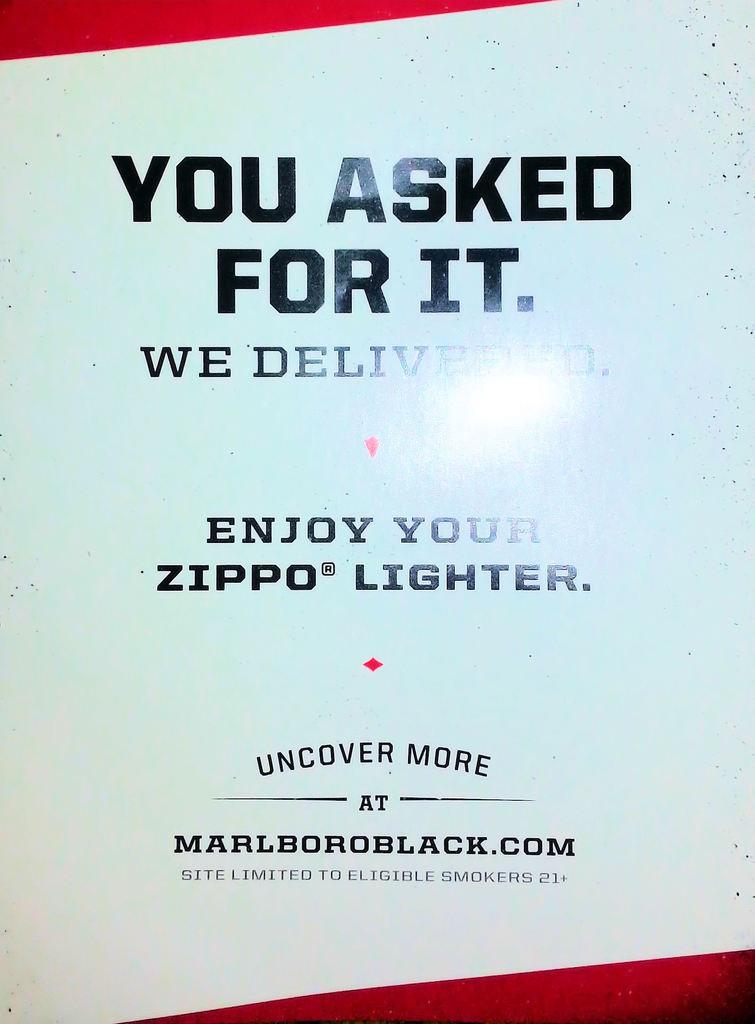What is the website name?
Provide a succinct answer. Marlboroblack.com. What is the main title of the image?
Provide a succinct answer. You asked for it. 